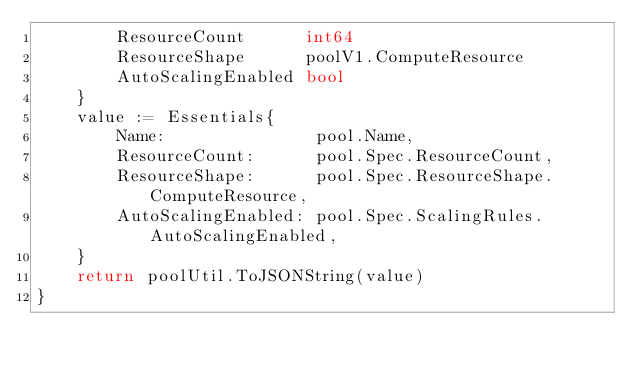Convert code to text. <code><loc_0><loc_0><loc_500><loc_500><_Go_>		ResourceCount      int64
		ResourceShape      poolV1.ComputeResource
		AutoScalingEnabled bool
	}
	value := Essentials{
		Name:               pool.Name,
		ResourceCount:      pool.Spec.ResourceCount,
		ResourceShape:      pool.Spec.ResourceShape.ComputeResource,
		AutoScalingEnabled: pool.Spec.ScalingRules.AutoScalingEnabled,
	}
	return poolUtil.ToJSONString(value)
}
</code> 